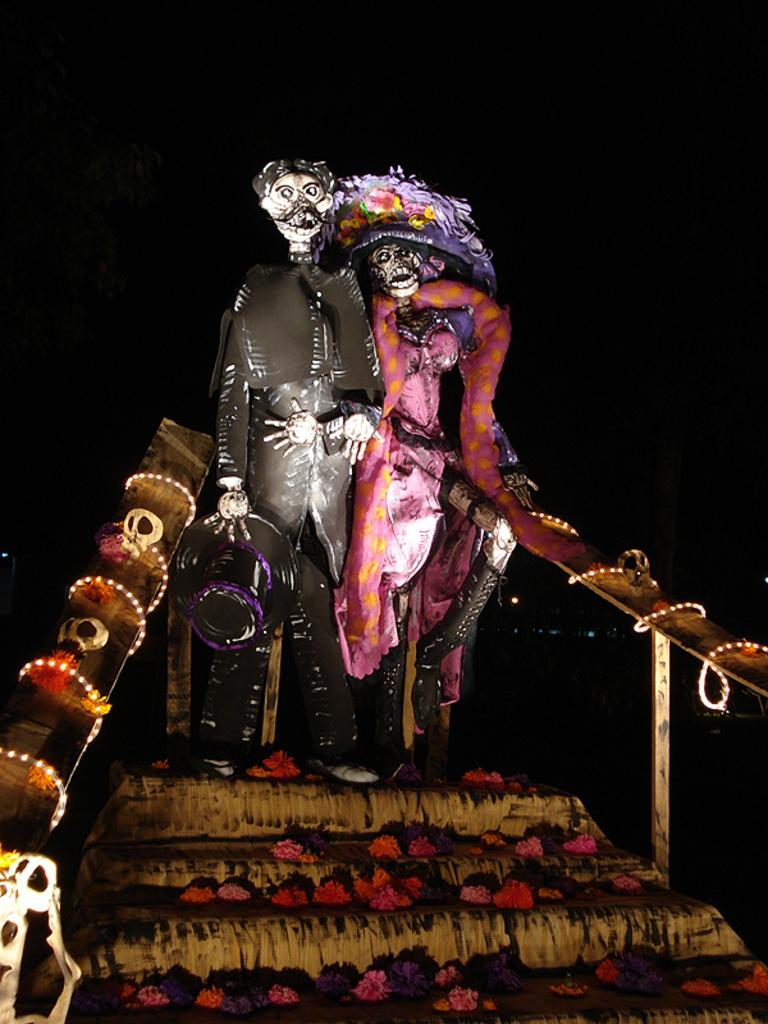How many scarecrows are present in the image? There are two scarecrows in the image. Where are the scarecrows located? The scarecrows are standing on the steps. What is supporting the scarecrows on the steps? There are wooden sticks on either side of the scarecrows. What can be seen growing on the steps? There are flowers on the steps. What type of advice is the scarecrow giving to the balls in the image? There are no balls present in the image, and the scarecrows are not giving any advice. 